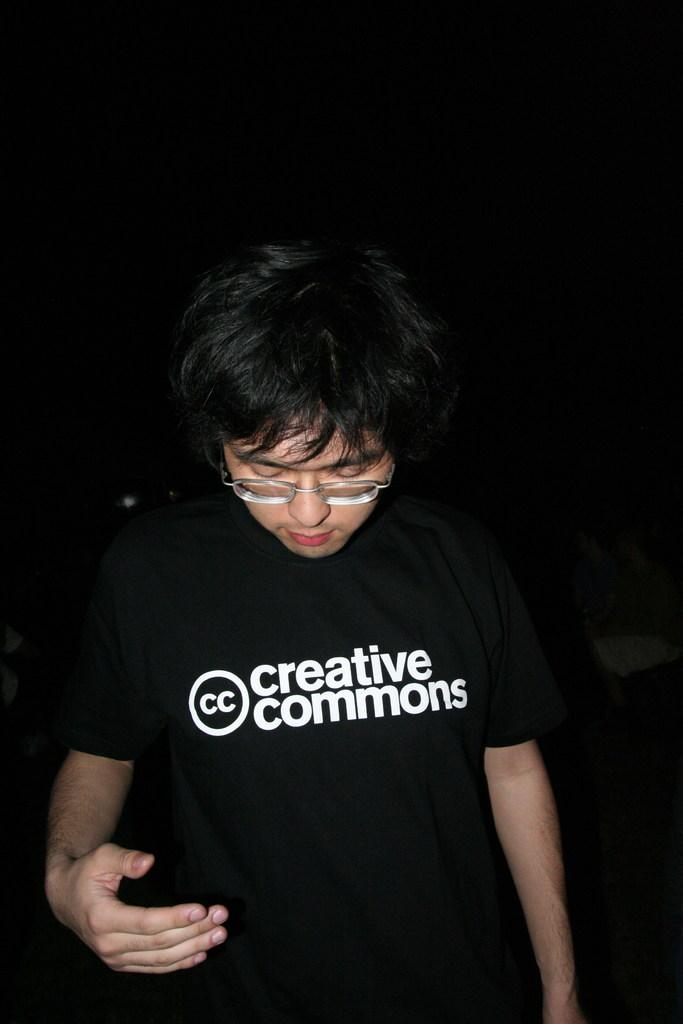Who is the main subject in the image? There is a man in the image. What is the man wearing? The man is wearing a black t-shirt. What is the man doing in the image? The man is standing. What can be seen behind the man in the image? There is a dark background in the image. What type of yard can be seen in the image? There is no yard present in the image; it features a man standing in front of a dark background. How does the man comfort his child in the image? There is no child present in the image, and the man is not shown comforting anyone. 